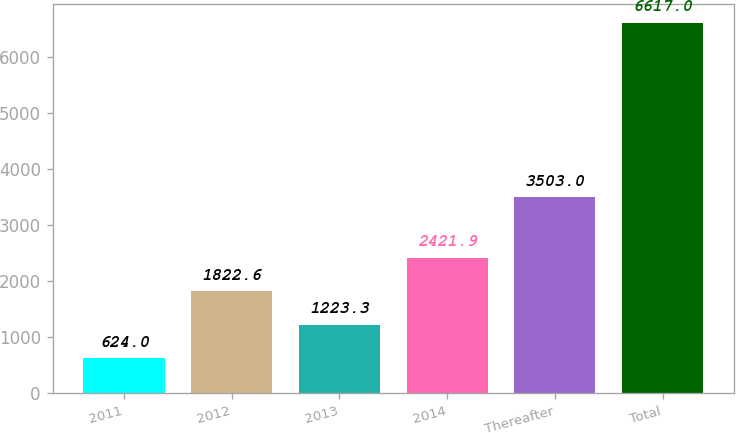Convert chart to OTSL. <chart><loc_0><loc_0><loc_500><loc_500><bar_chart><fcel>2011<fcel>2012<fcel>2013<fcel>2014<fcel>Thereafter<fcel>Total<nl><fcel>624<fcel>1822.6<fcel>1223.3<fcel>2421.9<fcel>3503<fcel>6617<nl></chart> 